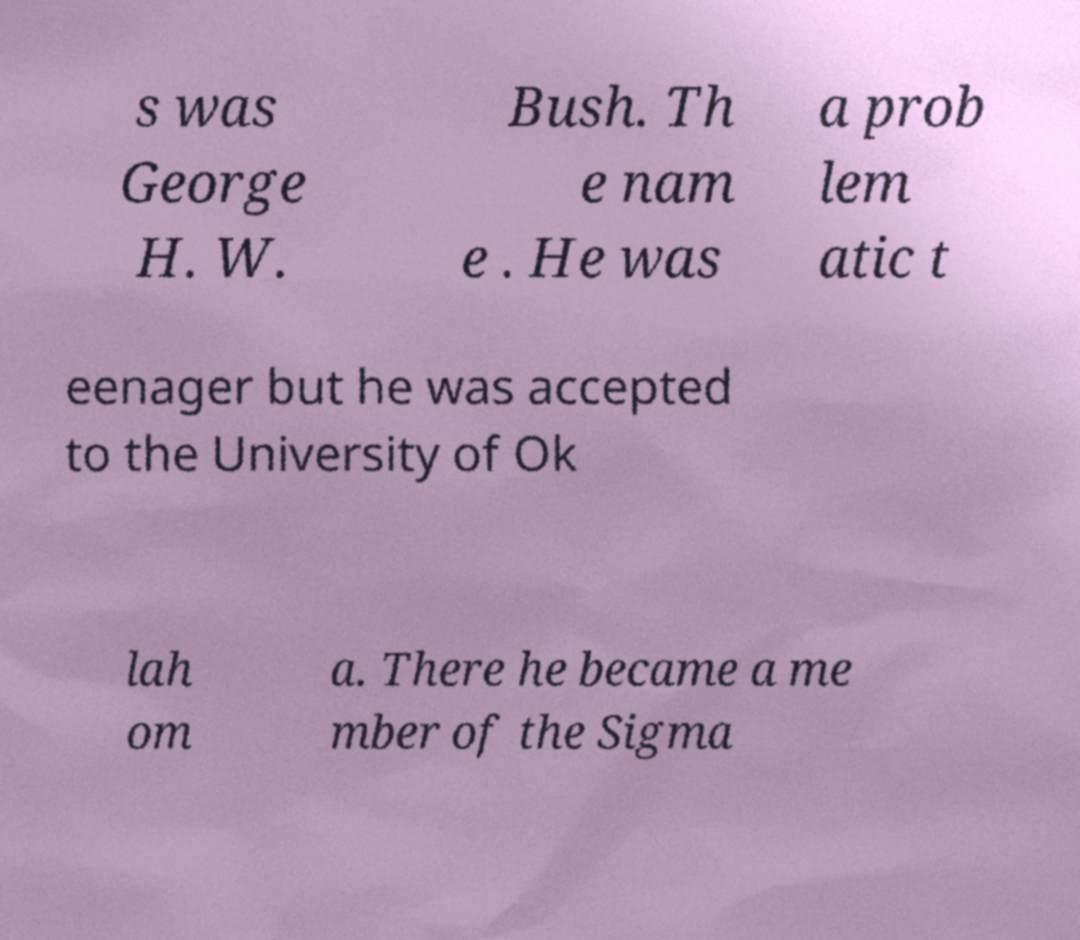Can you read and provide the text displayed in the image?This photo seems to have some interesting text. Can you extract and type it out for me? s was George H. W. Bush. Th e nam e . He was a prob lem atic t eenager but he was accepted to the University of Ok lah om a. There he became a me mber of the Sigma 